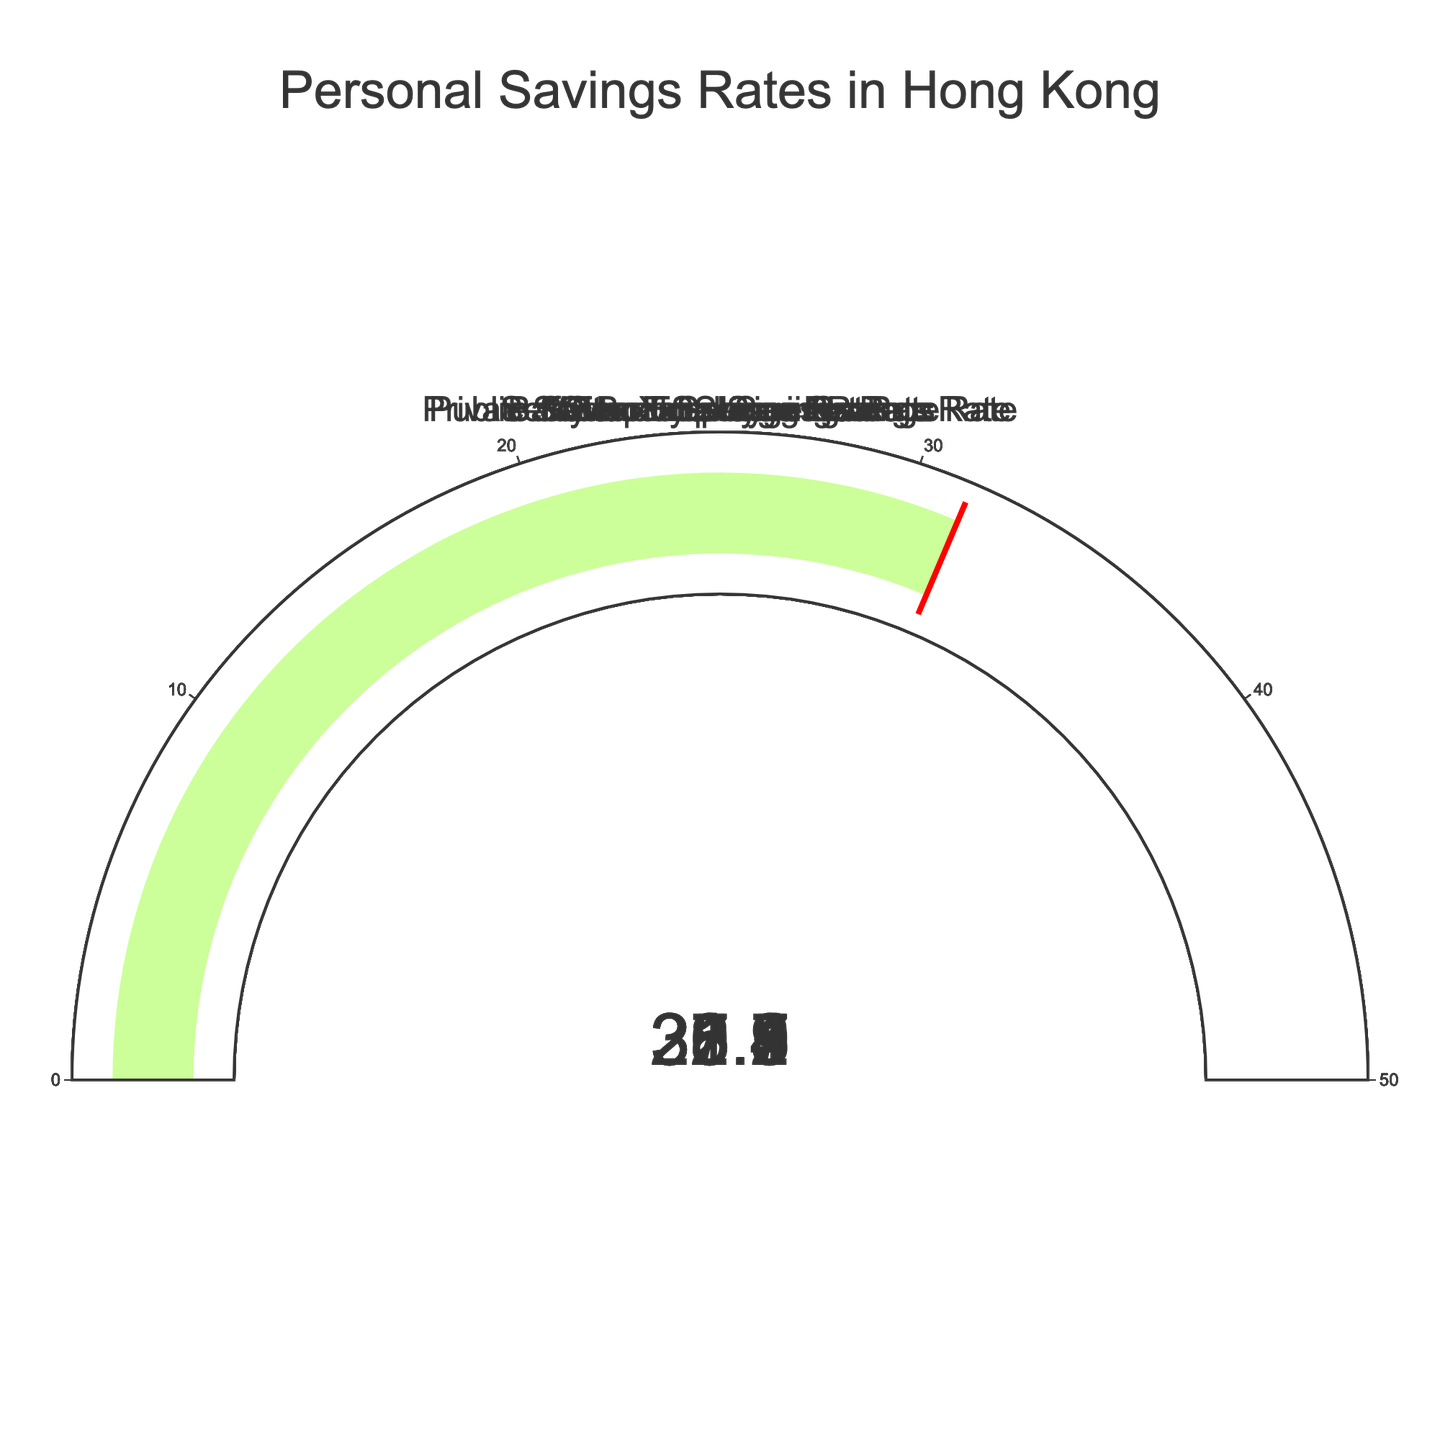What's the overall savings rate of Hong Kong residents? The "Overall Savings Rate" gauge shows a value of 30.5.
Answer: 30.5 Which age group has the highest savings rate? The Baby Boomer Savings Rate shows the highest value among the age groups, at 35.2.
Answer: Baby Boomers What's the difference between the Baby Boomer savings rate and the Millennial savings rate? Subtract the Millennial savings rate (22.1) from the Baby Boomer savings rate (35.2), which equals 13.1.
Answer: 13.1 Among public sector employees, private sector employees, and self-employed individuals, who saves the most? The Public Sector Employee Savings Rate is 33.8, which is the highest among the three groups.
Answer: Public Sector Employees What is the average savings rate for private sector employees and self-employed individuals? Add the Private Sector Employee Savings Rate (27.9) and Self-Employed Savings Rate (31.4), then divide by 2. The calculation is (27.9 + 31.4) / 2 = 29.65.
Answer: 29.65 How does the savings rate of Gen X compare to the overall savings rate? The Gen X Savings Rate is 28.7, which is lower than the Overall Savings Rate of 30.5.
Answer: Gen X is lower Which group has a savings rate closest to the overall savings rate of 30.5? The Self-Employed Savings Rate is 31.4, which is the closest to 30.5 when compared to the other groups.
Answer: Self-Employed What is the difference in savings rates between public sector employees and private sector employees? Subtract the Private Sector Employee Savings Rate (27.9) from the Public Sector Employee Savings Rate (33.8), which equals 5.9.
Answer: 5.9 